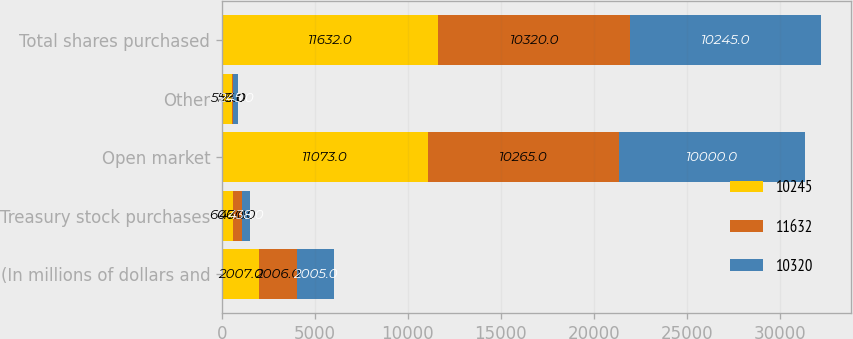<chart> <loc_0><loc_0><loc_500><loc_500><stacked_bar_chart><ecel><fcel>(In millions of dollars and<fcel>Treasury stock purchases<fcel>Open market<fcel>Other<fcel>Total shares purchased<nl><fcel>10245<fcel>2007<fcel>606<fcel>11073<fcel>559<fcel>11632<nl><fcel>11632<fcel>2006<fcel>470<fcel>10265<fcel>55<fcel>10320<nl><fcel>10320<fcel>2005<fcel>438<fcel>10000<fcel>245<fcel>10245<nl></chart> 